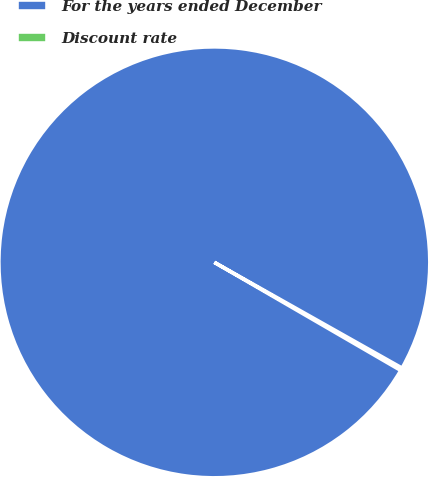Convert chart. <chart><loc_0><loc_0><loc_500><loc_500><pie_chart><fcel>For the years ended December<fcel>Discount rate<nl><fcel>99.8%<fcel>0.2%<nl></chart> 